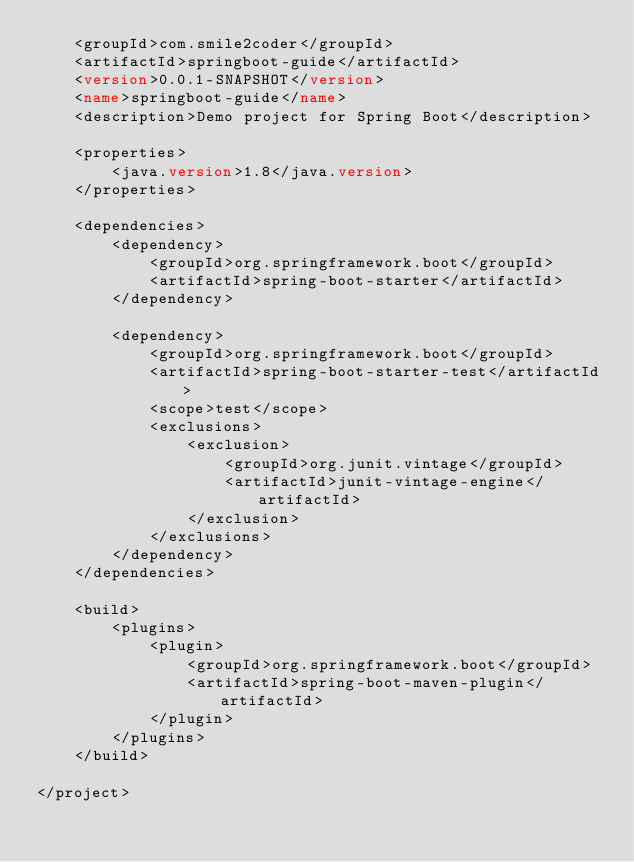Convert code to text. <code><loc_0><loc_0><loc_500><loc_500><_XML_>    <groupId>com.smile2coder</groupId>
    <artifactId>springboot-guide</artifactId>
    <version>0.0.1-SNAPSHOT</version>
    <name>springboot-guide</name>
    <description>Demo project for Spring Boot</description>

    <properties>
        <java.version>1.8</java.version>
    </properties>

    <dependencies>
        <dependency>
            <groupId>org.springframework.boot</groupId>
            <artifactId>spring-boot-starter</artifactId>
        </dependency>

        <dependency>
            <groupId>org.springframework.boot</groupId>
            <artifactId>spring-boot-starter-test</artifactId>
            <scope>test</scope>
            <exclusions>
                <exclusion>
                    <groupId>org.junit.vintage</groupId>
                    <artifactId>junit-vintage-engine</artifactId>
                </exclusion>
            </exclusions>
        </dependency>
    </dependencies>

    <build>
        <plugins>
            <plugin>
                <groupId>org.springframework.boot</groupId>
                <artifactId>spring-boot-maven-plugin</artifactId>
            </plugin>
        </plugins>
    </build>

</project>
</code> 